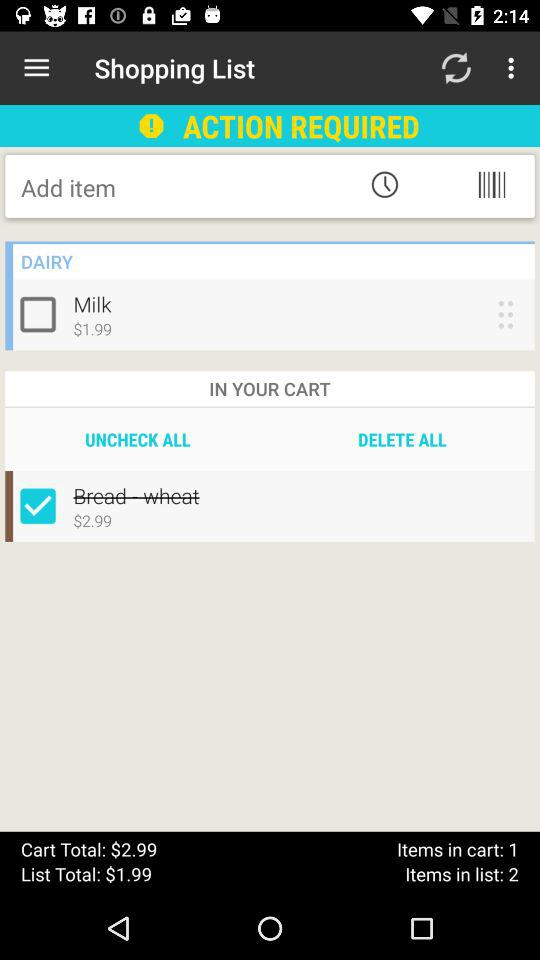What is the price of milk? The price is $1.99. 